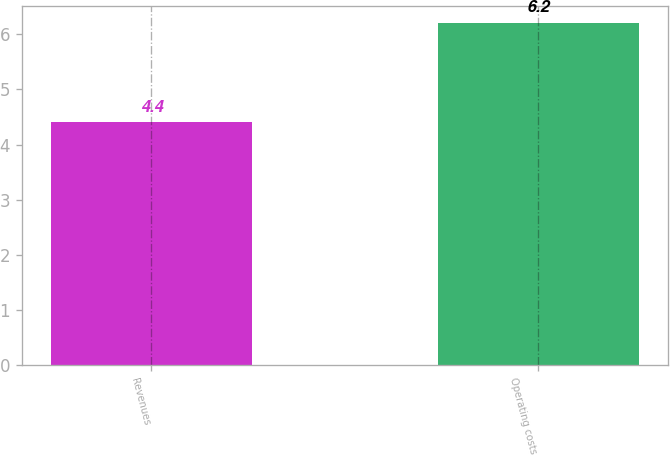Convert chart. <chart><loc_0><loc_0><loc_500><loc_500><bar_chart><fcel>Revenues<fcel>Operating costs<nl><fcel>4.4<fcel>6.2<nl></chart> 